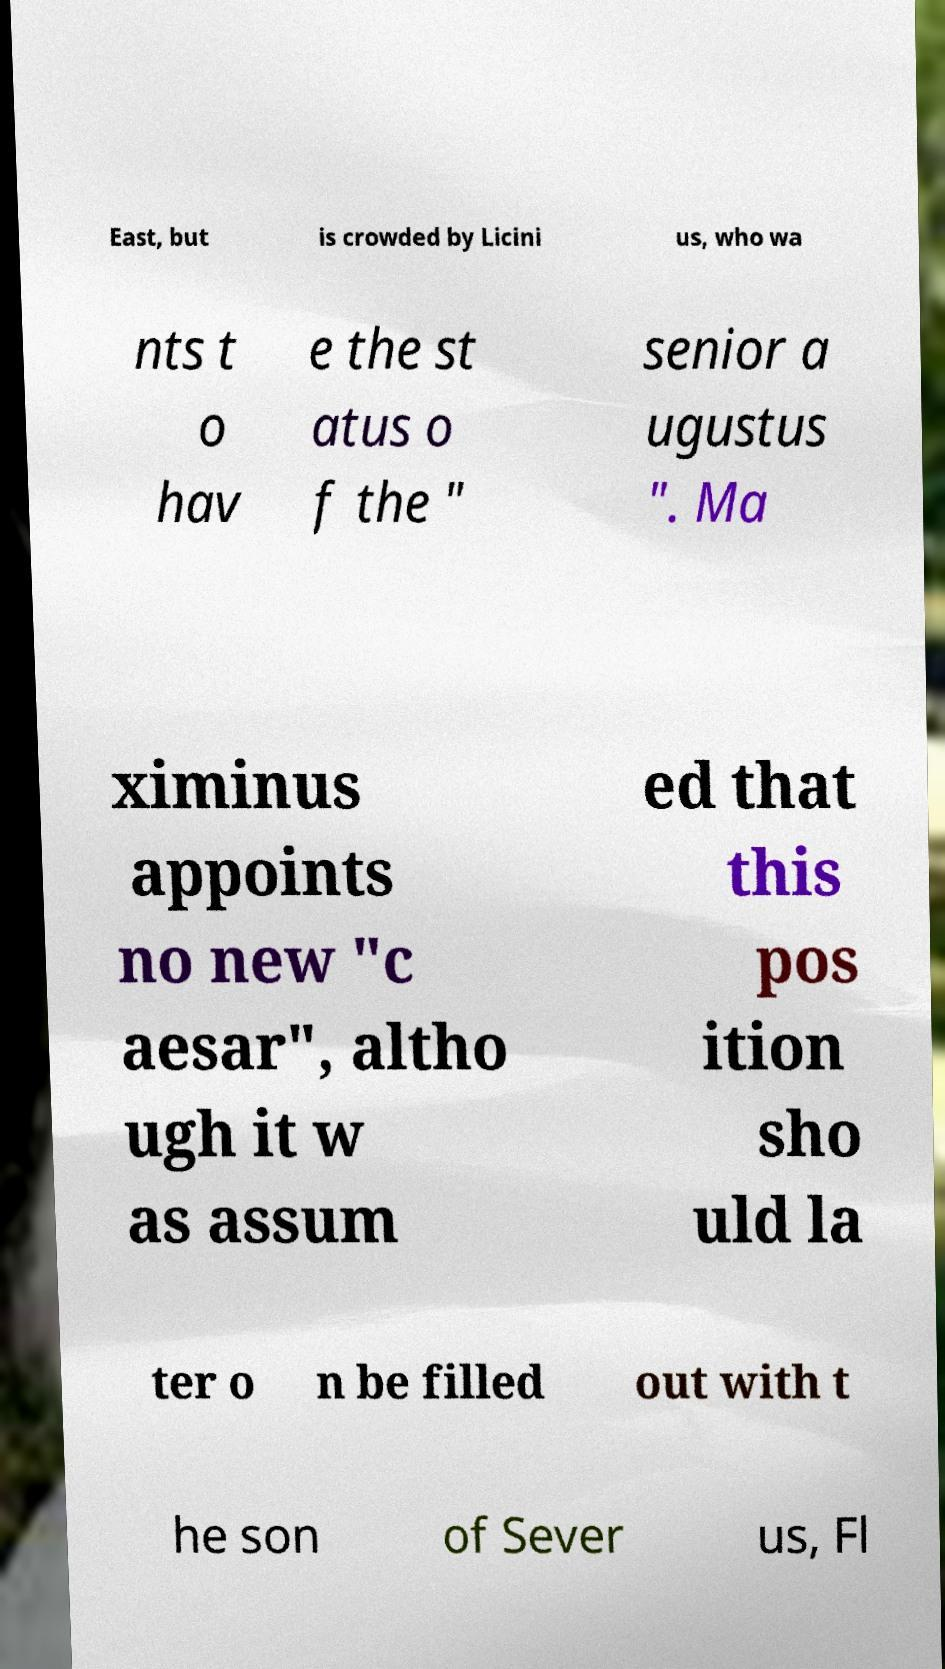Can you accurately transcribe the text from the provided image for me? East, but is crowded by Licini us, who wa nts t o hav e the st atus o f the " senior a ugustus ". Ma ximinus appoints no new "c aesar", altho ugh it w as assum ed that this pos ition sho uld la ter o n be filled out with t he son of Sever us, Fl 